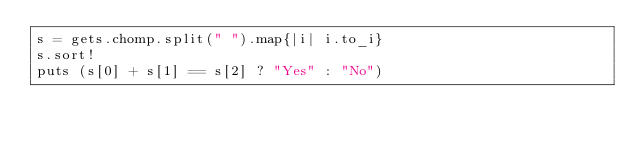<code> <loc_0><loc_0><loc_500><loc_500><_Ruby_>s = gets.chomp.split(" ").map{|i| i.to_i}
s.sort!
puts (s[0] + s[1] == s[2] ? "Yes" : "No")
</code> 